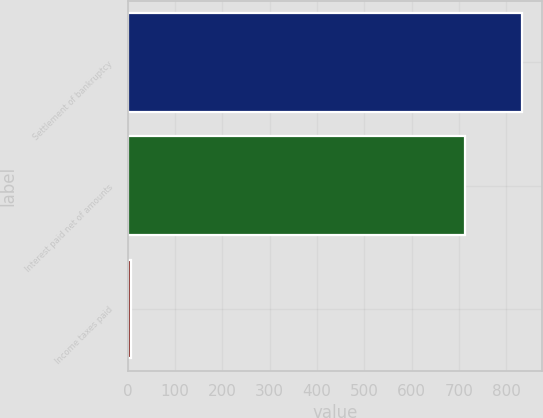Convert chart. <chart><loc_0><loc_0><loc_500><loc_500><bar_chart><fcel>Settlement of bankruptcy<fcel>Interest paid net of amounts<fcel>Income taxes paid<nl><fcel>833<fcel>712<fcel>7<nl></chart> 